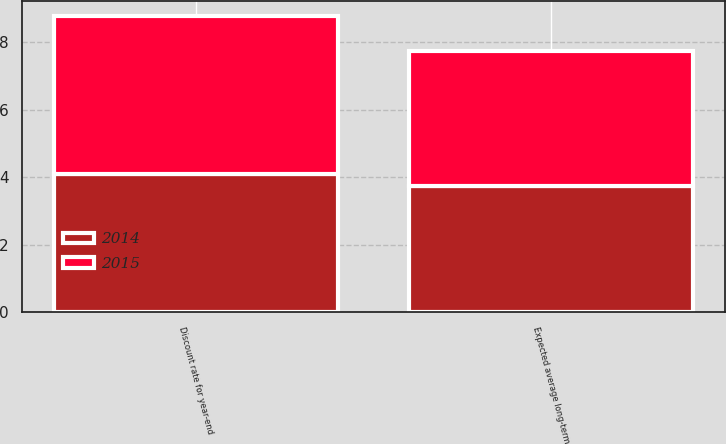Convert chart. <chart><loc_0><loc_0><loc_500><loc_500><stacked_bar_chart><ecel><fcel>Discount rate for year-end<fcel>Expected average long-term<nl><fcel>2015<fcel>4.66<fcel>4<nl><fcel>2014<fcel>4.11<fcel>3.75<nl></chart> 